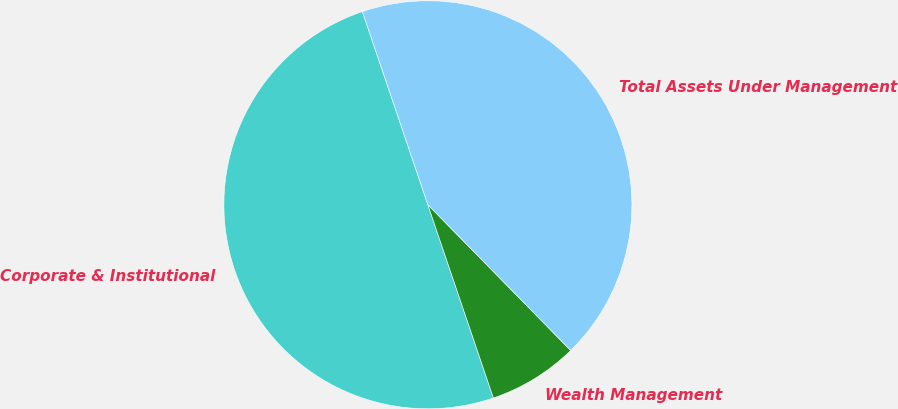Convert chart to OTSL. <chart><loc_0><loc_0><loc_500><loc_500><pie_chart><fcel>Corporate & Institutional<fcel>Wealth Management<fcel>Total Assets Under Management<nl><fcel>50.0%<fcel>7.14%<fcel>42.86%<nl></chart> 